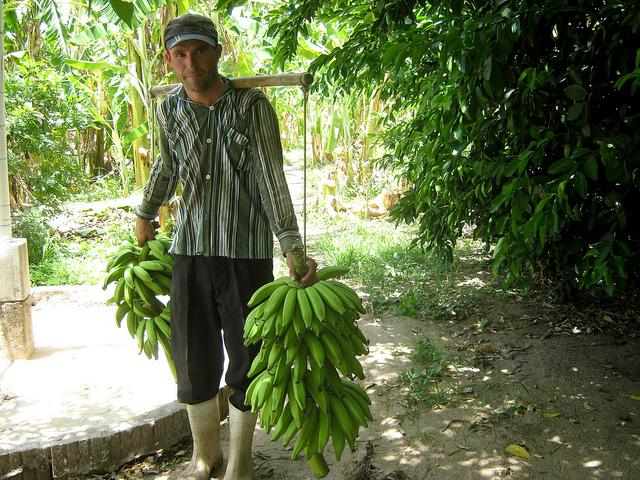Is the man holding bananas?
Quick response, please. Yes. Is there fruit in the photo?
Concise answer only. Yes. Is the fruit ripe?
Quick response, please. No. 